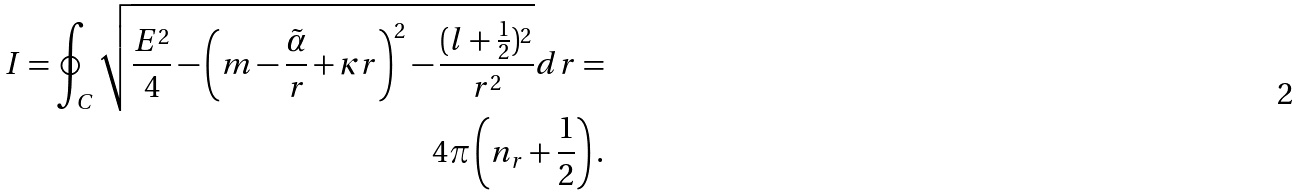<formula> <loc_0><loc_0><loc_500><loc_500>I = \oint _ { C } \sqrt { \frac { E ^ { 2 } } 4 - \left ( m - \frac { \tilde { \alpha } } r + \kappa r \right ) ^ { 2 } - \frac { ( l + \frac { 1 } { 2 } ) ^ { 2 } } { r ^ { 2 } } } d r = \\ 4 \pi \left ( n _ { r } + \frac { 1 } { 2 } \right ) .</formula> 